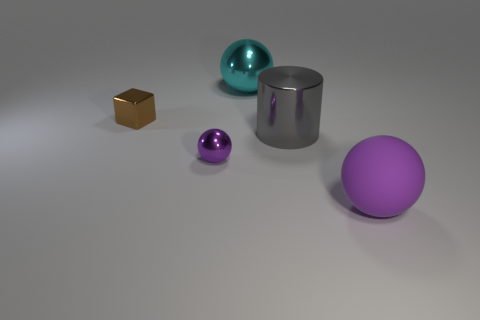Add 5 big rubber objects. How many objects exist? 10 Subtract all purple matte spheres. How many spheres are left? 2 Subtract all cyan balls. How many balls are left? 2 Subtract all cubes. How many objects are left? 4 Add 5 tiny blue shiny objects. How many tiny blue shiny objects exist? 5 Subtract 1 gray cylinders. How many objects are left? 4 Subtract all cyan spheres. Subtract all gray cubes. How many spheres are left? 2 Subtract all gray blocks. How many cyan balls are left? 1 Subtract all small green blocks. Subtract all large objects. How many objects are left? 2 Add 4 big gray shiny objects. How many big gray shiny objects are left? 5 